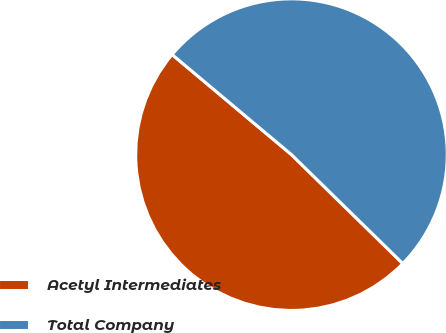Convert chart to OTSL. <chart><loc_0><loc_0><loc_500><loc_500><pie_chart><fcel>Acetyl Intermediates<fcel>Total Company<nl><fcel>48.78%<fcel>51.22%<nl></chart> 